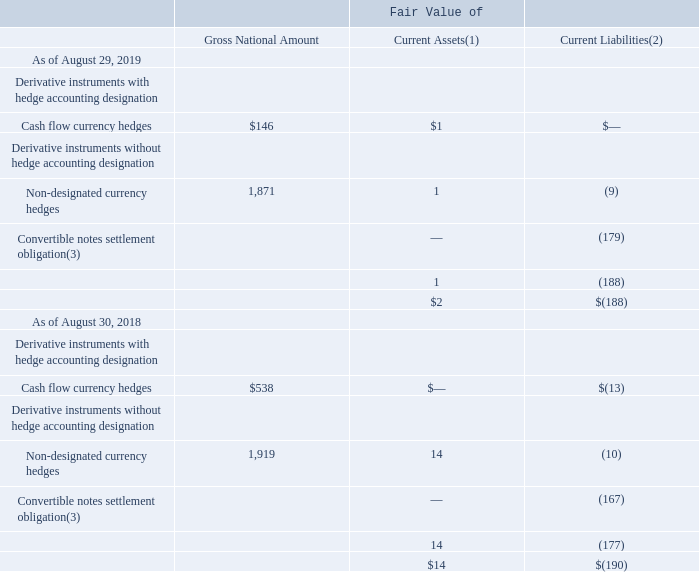Derivative Instruments
Derivative Instruments with Hedge Accounting Designation
We utilize currency forward contracts that generally mature within 12 months to hedge our exposure to changes in currency exchange rates. Currency forward contracts are measured at fair value based on market-based observable inputs including currency exchange spot and forward rates, interest rates, and credit-risk spreads (Level 2). We do not use derivative instruments for speculative purposes.
Cash Flow Hedges: We utilize cash flow hedges for our exposure from changes in currency exchange rates for certain capital expenditures. We recognized losses of $3 million and $17 million and gains of $15 million for 2019, 2018, and 2017, respectively, in accumulated other comprehensive income from the effective portion of cash flow hedges. Neither the amount excluded from hedge effectiveness nor the reclassifications from accumulated other comprehensive income to earnings were material in 2019, 2018, or 2017. The amounts from cash flow hedges included in accumulated other comprehensive income that are expected to be reclassified into earnings in the next 12 months were also not material.
(1) Included in receivables – other.
(2) Included in accounts payable and accrued expenses – other for forward contracts and in current debt for convertible notes settlement obligations.
(3) Notional amounts of convertible notes settlement obligations as of August 29, 2019 and August 30, 2018 were 4 million and 3 million shares of our common stock, respectively.
How does the company measure currency forward contracts? At fair value based on market-based observable inputs including currency exchange spot and forward rates, interest rates, and credit-risk spreads (level 2). How does the company utilize its cash flow hedges? For our exposure from changes in currency exchange rates for certain capital expenditures. What was the cash flow currency hedges as of August 29, 2019? $146. What is the change of the gross national amount of cash flow currency hedges from 2018 to 2019? 146 - 538 
Answer: -392. What is the average gross national amount of non-designated currency hedges from 2018 to 2019? (1,871+1,919)/2 
Answer: 1895. What is the ratio of the fair value of the total current assets in 2019 to that of 2018? 2/14 
Answer: 0.14. 